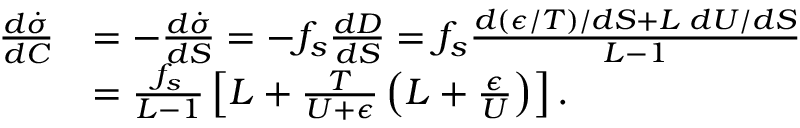Convert formula to latex. <formula><loc_0><loc_0><loc_500><loc_500>\begin{array} { r l } { \frac { d \dot { \sigma } } { d C } } & { = - \frac { d \dot { \sigma } } { d S } = - f _ { s } \frac { d D } { d S } = f _ { s } \frac { d ( \epsilon / T ) / d S + L \, d U / d S } { L - 1 } } \\ & { = \frac { f _ { s } } { L - 1 } \left [ L + \frac { T } { U + \epsilon } \left ( L + \frac { \epsilon } { U } \right ) \right ] . } \end{array}</formula> 